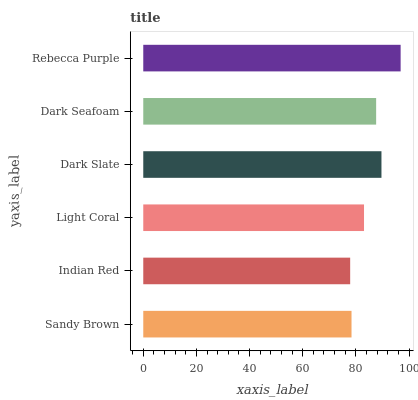Is Indian Red the minimum?
Answer yes or no. Yes. Is Rebecca Purple the maximum?
Answer yes or no. Yes. Is Light Coral the minimum?
Answer yes or no. No. Is Light Coral the maximum?
Answer yes or no. No. Is Light Coral greater than Indian Red?
Answer yes or no. Yes. Is Indian Red less than Light Coral?
Answer yes or no. Yes. Is Indian Red greater than Light Coral?
Answer yes or no. No. Is Light Coral less than Indian Red?
Answer yes or no. No. Is Dark Seafoam the high median?
Answer yes or no. Yes. Is Light Coral the low median?
Answer yes or no. Yes. Is Sandy Brown the high median?
Answer yes or no. No. Is Rebecca Purple the low median?
Answer yes or no. No. 